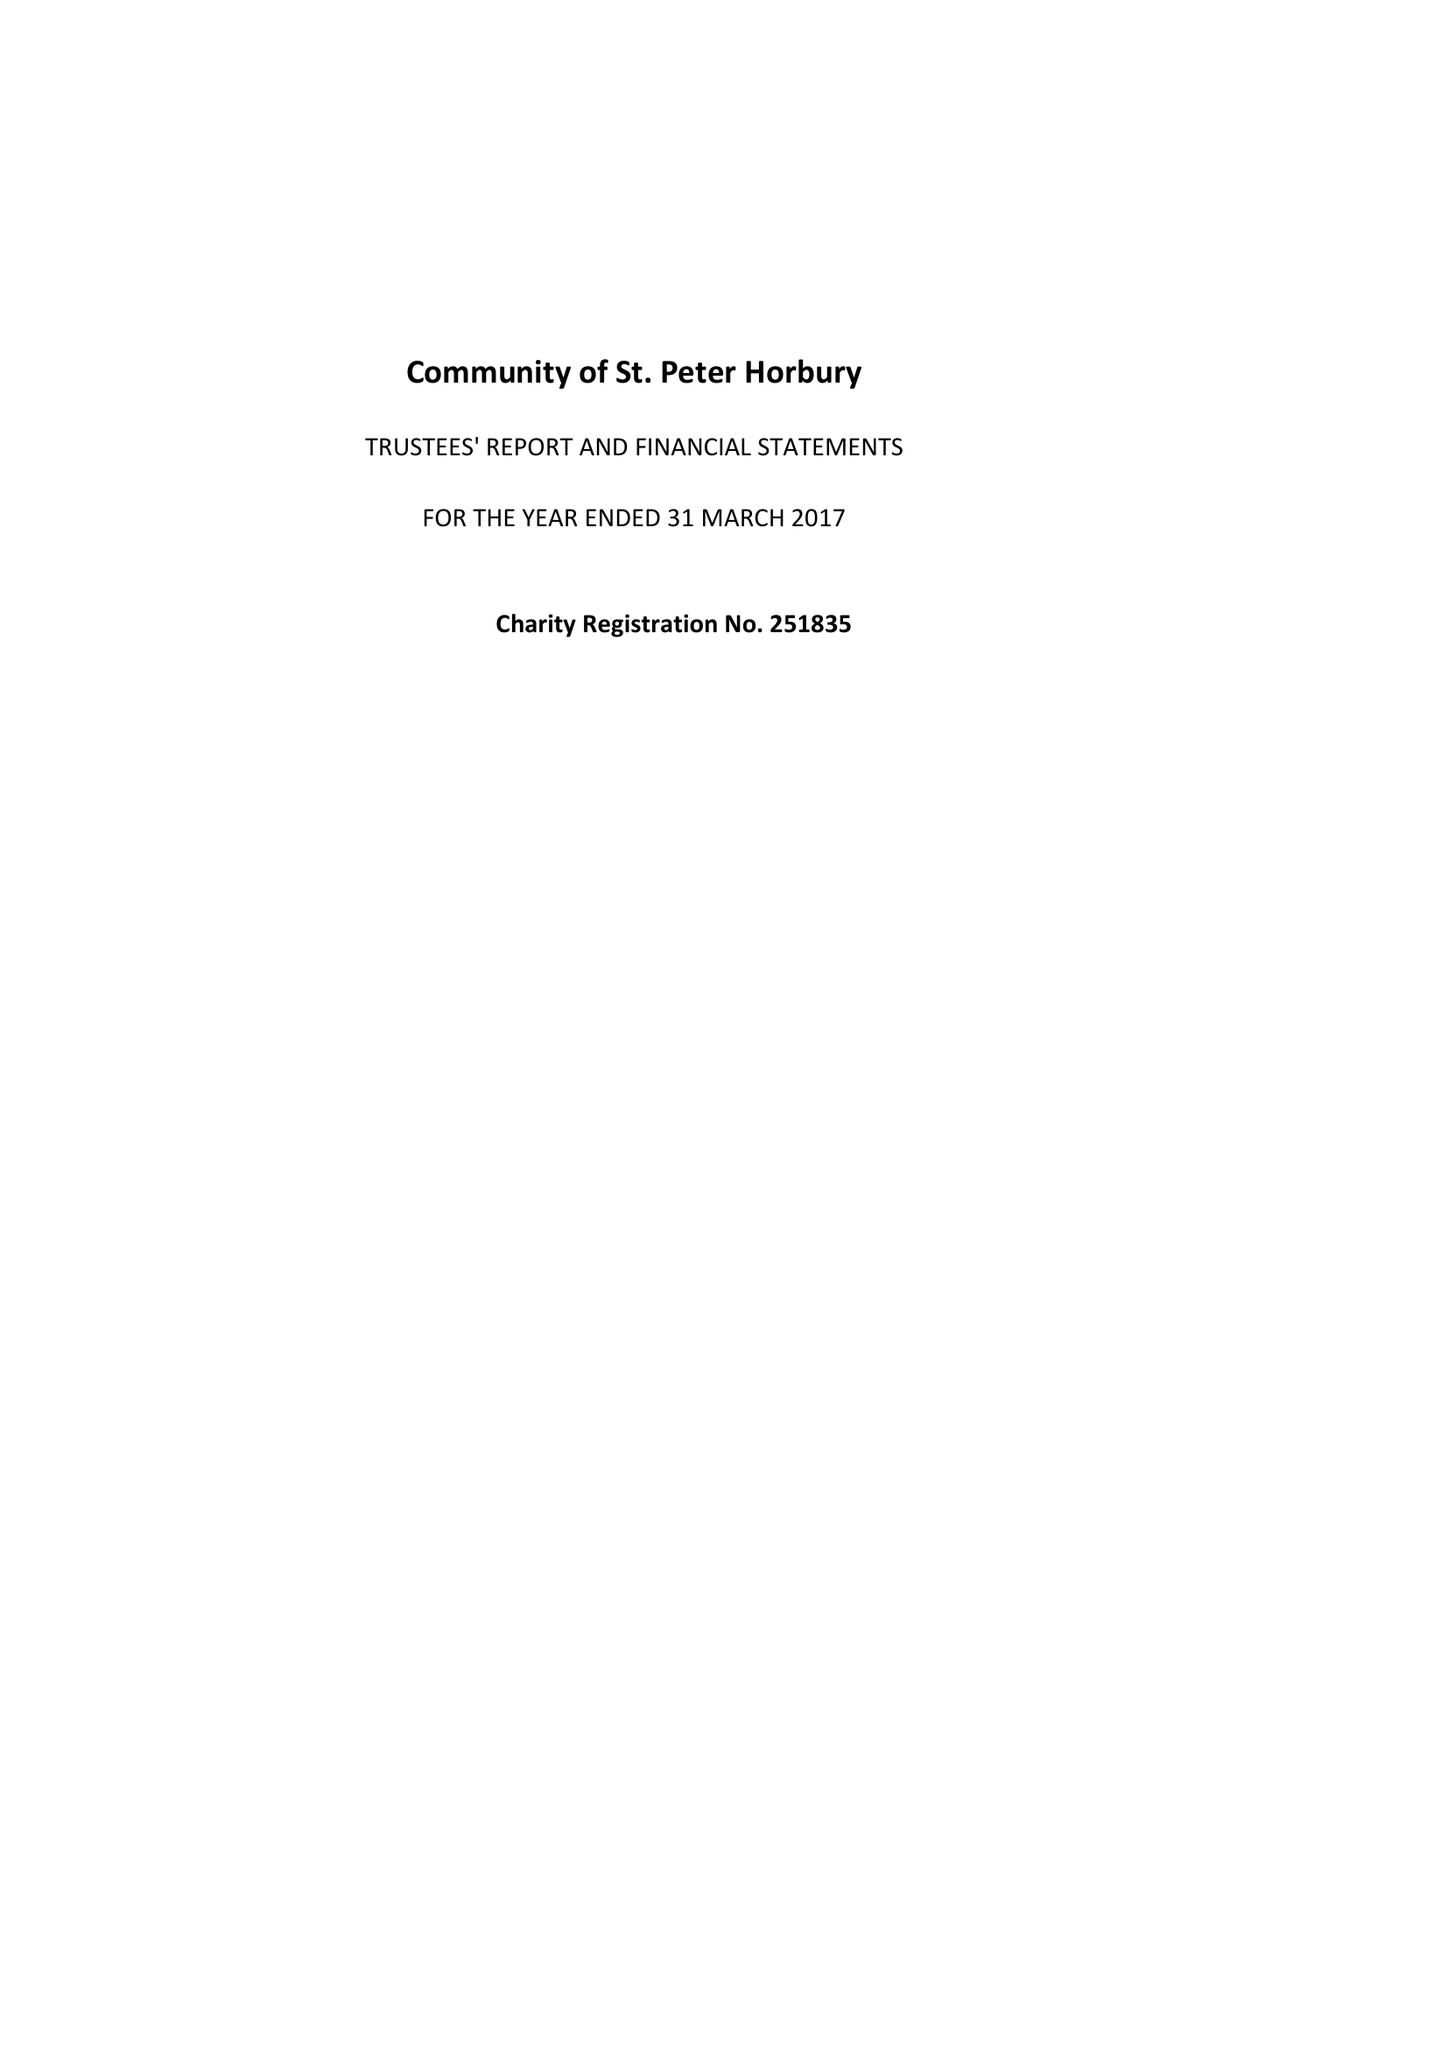What is the value for the address__postcode?
Answer the question using a single word or phrase. WF4 6DB 